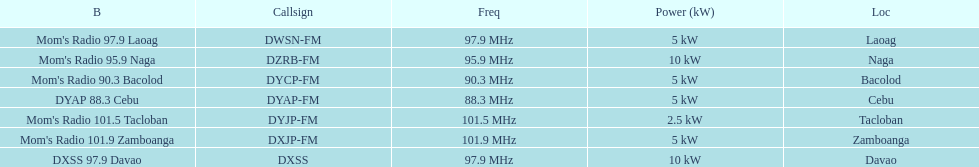Which of these stations broadcasts with the least power? Mom's Radio 101.5 Tacloban. 